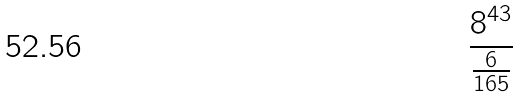Convert formula to latex. <formula><loc_0><loc_0><loc_500><loc_500>\frac { 8 ^ { 4 3 } } { \frac { 6 } { 1 6 5 } }</formula> 